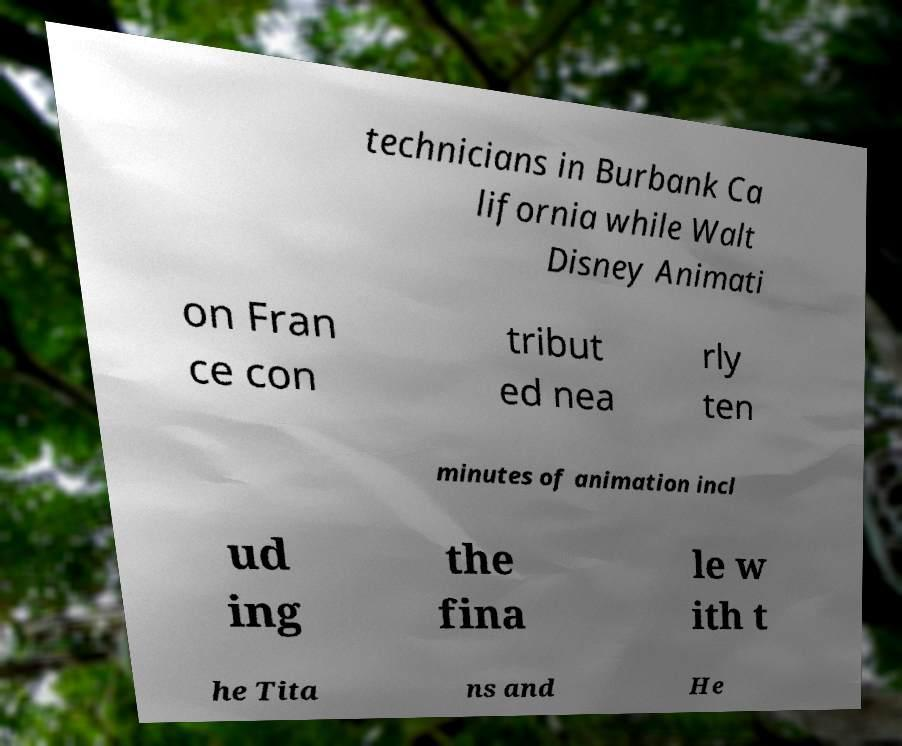Please read and relay the text visible in this image. What does it say? technicians in Burbank Ca lifornia while Walt Disney Animati on Fran ce con tribut ed nea rly ten minutes of animation incl ud ing the fina le w ith t he Tita ns and He 